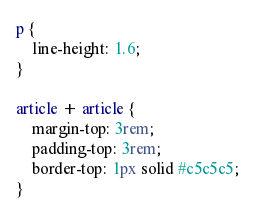<code> <loc_0><loc_0><loc_500><loc_500><_CSS_>
p {
    line-height: 1.6;
}

article + article {
    margin-top: 3rem;
    padding-top: 3rem;
    border-top: 1px solid #c5c5c5;
}</code> 